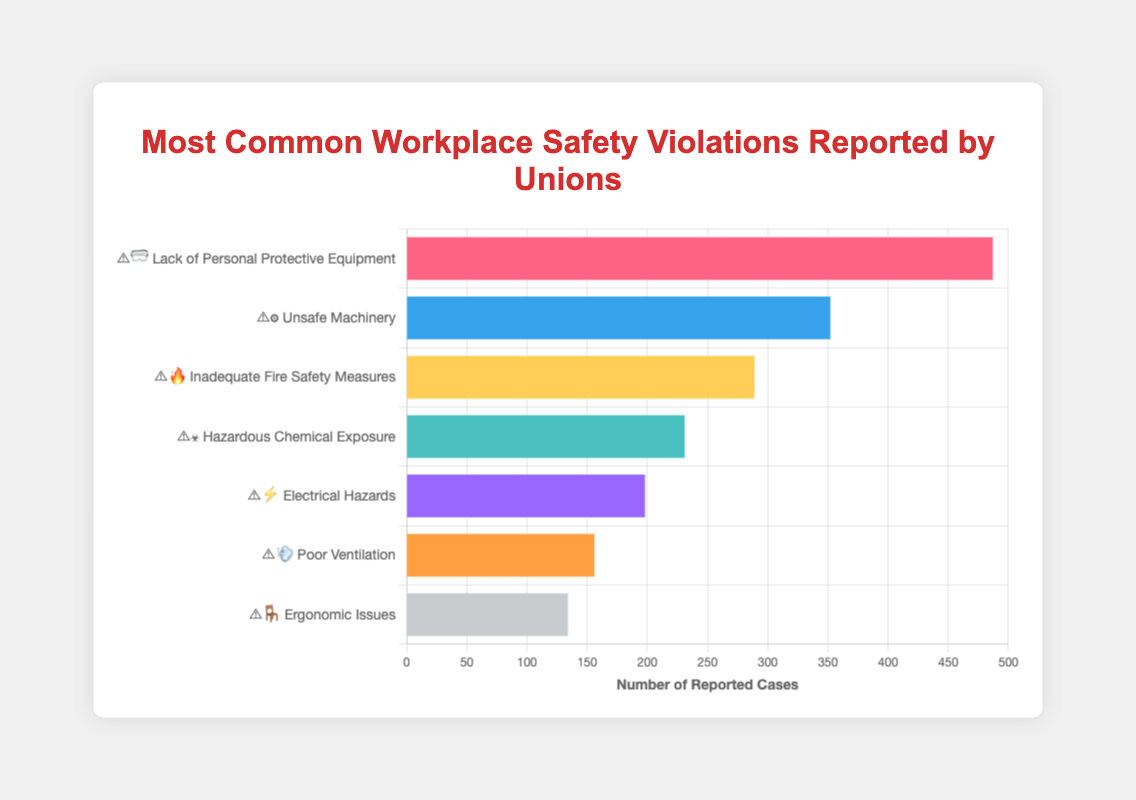What is the most common workplace safety violation reported by unions? The bar for 'Lack of Personal Protective Equipment' is the tallest, indicating that it has the highest count of reported cases.
Answer: Lack of Personal Protective Equipment How many cases of 'Electrical Hazards' were reported? The bar representing 'Electrical Hazards' is labeled with 198 cases.
Answer: 198 What's the total number of reported cases for all types of violations combined? Add the counts for all types: 487 + 352 + 289 + 231 + 198 + 156 + 134 = 1847
Answer: 1847 Compare the number of reported cases of 'Unsafe Machinery' and 'Hazardous Chemical Exposure'. Which has more? 'Unsafe Machinery' has 352 reported cases, while 'Hazardous Chemical Exposure' has 231 cases. 352 is greater than 231.
Answer: Unsafe Machinery What violation type has the fewest reported cases? The bar for 'Ergonomic Issues' is the shortest, indicating that it has the lowest count of reported cases.
Answer: Ergonomic Issues How many more cases of 'Lack of Personal Protective Equipment' are there compared to 'Poor Ventilation'? Subtract the number of 'Poor Ventilation' cases from 'Lack of Personal Protective Equipment': 487 - 156 = 331
Answer: 331 What's the average number of reported cases across all types of violations? Sum all counts (1847) and divide by the number of types (7): 1847 / 7 ≈ 264
Answer: 264 What is the difference in reported cases between 'Inadequate Fire Safety Measures' and 'Electrical Hazards'? Subtract the number of 'Electrical Hazards' cases from 'Inadequate Fire Safety Measures': 289 - 198 = 91
Answer: 91 Which types of violations are represented by emoji involving fire and electricity? The violations with fire (🔥) and electricity (⚡) emojis are 'Inadequate Fire Safety Measures' and 'Electrical Hazards', respectively.
Answer: Inadequate Fire Safety Measures and Electrical Hazards Identify the violations labeled with a '⚠️' emoji. All listed violations in the figure begin with a '⚠️' emoji, indicating a warning.
Answer: All violations 